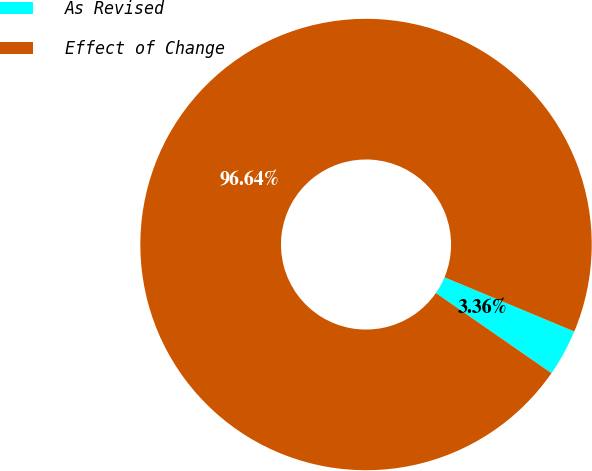Convert chart. <chart><loc_0><loc_0><loc_500><loc_500><pie_chart><fcel>As Revised<fcel>Effect of Change<nl><fcel>3.36%<fcel>96.64%<nl></chart> 